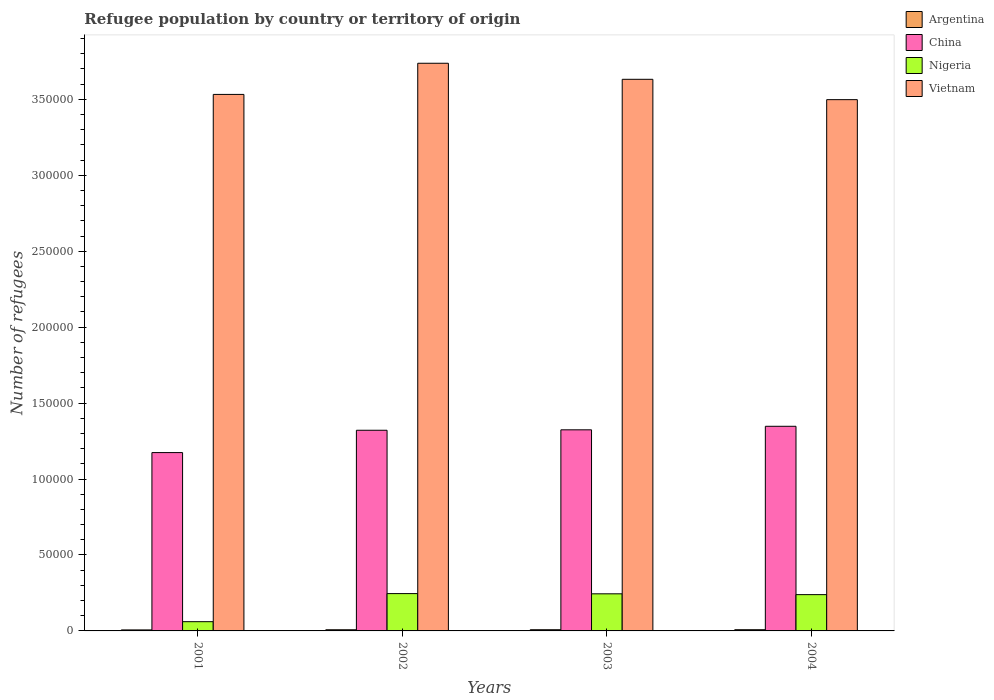How many different coloured bars are there?
Make the answer very short. 4. How many groups of bars are there?
Ensure brevity in your answer.  4. Are the number of bars per tick equal to the number of legend labels?
Your response must be concise. Yes. Are the number of bars on each tick of the X-axis equal?
Make the answer very short. Yes. How many bars are there on the 3rd tick from the right?
Provide a succinct answer. 4. In how many cases, is the number of bars for a given year not equal to the number of legend labels?
Your response must be concise. 0. What is the number of refugees in Argentina in 2001?
Ensure brevity in your answer.  659. Across all years, what is the maximum number of refugees in Argentina?
Provide a succinct answer. 796. Across all years, what is the minimum number of refugees in Argentina?
Your response must be concise. 659. What is the total number of refugees in China in the graph?
Your answer should be very brief. 5.17e+05. What is the difference between the number of refugees in Argentina in 2001 and that in 2002?
Provide a succinct answer. -112. What is the difference between the number of refugees in China in 2001 and the number of refugees in Nigeria in 2002?
Keep it short and to the point. 9.28e+04. What is the average number of refugees in Vietnam per year?
Ensure brevity in your answer.  3.60e+05. In the year 2001, what is the difference between the number of refugees in Argentina and number of refugees in China?
Give a very brief answer. -1.17e+05. What is the ratio of the number of refugees in China in 2001 to that in 2003?
Provide a succinct answer. 0.89. Is the difference between the number of refugees in Argentina in 2001 and 2003 greater than the difference between the number of refugees in China in 2001 and 2003?
Your answer should be compact. Yes. What is the difference between the highest and the second highest number of refugees in Vietnam?
Give a very brief answer. 1.06e+04. What is the difference between the highest and the lowest number of refugees in Nigeria?
Make the answer very short. 1.85e+04. Is the sum of the number of refugees in China in 2003 and 2004 greater than the maximum number of refugees in Argentina across all years?
Make the answer very short. Yes. What does the 3rd bar from the left in 2002 represents?
Give a very brief answer. Nigeria. What does the 3rd bar from the right in 2002 represents?
Provide a succinct answer. China. Is it the case that in every year, the sum of the number of refugees in Argentina and number of refugees in Nigeria is greater than the number of refugees in Vietnam?
Offer a very short reply. No. Are all the bars in the graph horizontal?
Offer a very short reply. No. How many years are there in the graph?
Make the answer very short. 4. What is the difference between two consecutive major ticks on the Y-axis?
Offer a terse response. 5.00e+04. Where does the legend appear in the graph?
Ensure brevity in your answer.  Top right. How many legend labels are there?
Offer a terse response. 4. How are the legend labels stacked?
Make the answer very short. Vertical. What is the title of the graph?
Offer a very short reply. Refugee population by country or territory of origin. What is the label or title of the Y-axis?
Provide a succinct answer. Number of refugees. What is the Number of refugees of Argentina in 2001?
Provide a succinct answer. 659. What is the Number of refugees in China in 2001?
Give a very brief answer. 1.17e+05. What is the Number of refugees in Nigeria in 2001?
Provide a succinct answer. 6084. What is the Number of refugees in Vietnam in 2001?
Keep it short and to the point. 3.53e+05. What is the Number of refugees in Argentina in 2002?
Provide a short and direct response. 771. What is the Number of refugees in China in 2002?
Your response must be concise. 1.32e+05. What is the Number of refugees in Nigeria in 2002?
Give a very brief answer. 2.46e+04. What is the Number of refugees of Vietnam in 2002?
Keep it short and to the point. 3.74e+05. What is the Number of refugees of Argentina in 2003?
Make the answer very short. 784. What is the Number of refugees of China in 2003?
Give a very brief answer. 1.32e+05. What is the Number of refugees in Nigeria in 2003?
Your response must be concise. 2.44e+04. What is the Number of refugees of Vietnam in 2003?
Your answer should be very brief. 3.63e+05. What is the Number of refugees in Argentina in 2004?
Give a very brief answer. 796. What is the Number of refugees in China in 2004?
Offer a very short reply. 1.35e+05. What is the Number of refugees in Nigeria in 2004?
Make the answer very short. 2.39e+04. What is the Number of refugees of Vietnam in 2004?
Ensure brevity in your answer.  3.50e+05. Across all years, what is the maximum Number of refugees of Argentina?
Your answer should be very brief. 796. Across all years, what is the maximum Number of refugees of China?
Your answer should be compact. 1.35e+05. Across all years, what is the maximum Number of refugees of Nigeria?
Your answer should be very brief. 2.46e+04. Across all years, what is the maximum Number of refugees in Vietnam?
Your answer should be compact. 3.74e+05. Across all years, what is the minimum Number of refugees of Argentina?
Ensure brevity in your answer.  659. Across all years, what is the minimum Number of refugees in China?
Offer a terse response. 1.17e+05. Across all years, what is the minimum Number of refugees of Nigeria?
Ensure brevity in your answer.  6084. Across all years, what is the minimum Number of refugees of Vietnam?
Keep it short and to the point. 3.50e+05. What is the total Number of refugees in Argentina in the graph?
Provide a succinct answer. 3010. What is the total Number of refugees of China in the graph?
Keep it short and to the point. 5.17e+05. What is the total Number of refugees in Nigeria in the graph?
Your response must be concise. 7.90e+04. What is the total Number of refugees of Vietnam in the graph?
Provide a short and direct response. 1.44e+06. What is the difference between the Number of refugees in Argentina in 2001 and that in 2002?
Make the answer very short. -112. What is the difference between the Number of refugees of China in 2001 and that in 2002?
Provide a succinct answer. -1.47e+04. What is the difference between the Number of refugees of Nigeria in 2001 and that in 2002?
Give a very brief answer. -1.85e+04. What is the difference between the Number of refugees in Vietnam in 2001 and that in 2002?
Your answer should be very brief. -2.05e+04. What is the difference between the Number of refugees in Argentina in 2001 and that in 2003?
Provide a succinct answer. -125. What is the difference between the Number of refugees of China in 2001 and that in 2003?
Your answer should be very brief. -1.50e+04. What is the difference between the Number of refugees in Nigeria in 2001 and that in 2003?
Give a very brief answer. -1.83e+04. What is the difference between the Number of refugees in Vietnam in 2001 and that in 2003?
Make the answer very short. -9955. What is the difference between the Number of refugees in Argentina in 2001 and that in 2004?
Give a very brief answer. -137. What is the difference between the Number of refugees of China in 2001 and that in 2004?
Ensure brevity in your answer.  -1.73e+04. What is the difference between the Number of refugees in Nigeria in 2001 and that in 2004?
Provide a short and direct response. -1.78e+04. What is the difference between the Number of refugees of Vietnam in 2001 and that in 2004?
Offer a very short reply. 3444. What is the difference between the Number of refugees of China in 2002 and that in 2003?
Your answer should be compact. -291. What is the difference between the Number of refugees in Nigeria in 2002 and that in 2003?
Your answer should be compact. 144. What is the difference between the Number of refugees in Vietnam in 2002 and that in 2003?
Ensure brevity in your answer.  1.06e+04. What is the difference between the Number of refugees of China in 2002 and that in 2004?
Give a very brief answer. -2609. What is the difference between the Number of refugees of Nigeria in 2002 and that in 2004?
Give a very brief answer. 680. What is the difference between the Number of refugees in Vietnam in 2002 and that in 2004?
Offer a very short reply. 2.40e+04. What is the difference between the Number of refugees of Argentina in 2003 and that in 2004?
Your response must be concise. -12. What is the difference between the Number of refugees in China in 2003 and that in 2004?
Give a very brief answer. -2318. What is the difference between the Number of refugees in Nigeria in 2003 and that in 2004?
Keep it short and to the point. 536. What is the difference between the Number of refugees in Vietnam in 2003 and that in 2004?
Provide a short and direct response. 1.34e+04. What is the difference between the Number of refugees in Argentina in 2001 and the Number of refugees in China in 2002?
Your answer should be very brief. -1.31e+05. What is the difference between the Number of refugees of Argentina in 2001 and the Number of refugees of Nigeria in 2002?
Provide a short and direct response. -2.39e+04. What is the difference between the Number of refugees in Argentina in 2001 and the Number of refugees in Vietnam in 2002?
Your response must be concise. -3.73e+05. What is the difference between the Number of refugees of China in 2001 and the Number of refugees of Nigeria in 2002?
Ensure brevity in your answer.  9.28e+04. What is the difference between the Number of refugees in China in 2001 and the Number of refugees in Vietnam in 2002?
Give a very brief answer. -2.56e+05. What is the difference between the Number of refugees of Nigeria in 2001 and the Number of refugees of Vietnam in 2002?
Your response must be concise. -3.68e+05. What is the difference between the Number of refugees in Argentina in 2001 and the Number of refugees in China in 2003?
Provide a short and direct response. -1.32e+05. What is the difference between the Number of refugees of Argentina in 2001 and the Number of refugees of Nigeria in 2003?
Provide a short and direct response. -2.38e+04. What is the difference between the Number of refugees of Argentina in 2001 and the Number of refugees of Vietnam in 2003?
Your answer should be compact. -3.63e+05. What is the difference between the Number of refugees in China in 2001 and the Number of refugees in Nigeria in 2003?
Your answer should be very brief. 9.30e+04. What is the difference between the Number of refugees in China in 2001 and the Number of refugees in Vietnam in 2003?
Keep it short and to the point. -2.46e+05. What is the difference between the Number of refugees in Nigeria in 2001 and the Number of refugees in Vietnam in 2003?
Provide a short and direct response. -3.57e+05. What is the difference between the Number of refugees in Argentina in 2001 and the Number of refugees in China in 2004?
Your response must be concise. -1.34e+05. What is the difference between the Number of refugees in Argentina in 2001 and the Number of refugees in Nigeria in 2004?
Provide a short and direct response. -2.32e+04. What is the difference between the Number of refugees in Argentina in 2001 and the Number of refugees in Vietnam in 2004?
Ensure brevity in your answer.  -3.49e+05. What is the difference between the Number of refugees in China in 2001 and the Number of refugees in Nigeria in 2004?
Keep it short and to the point. 9.35e+04. What is the difference between the Number of refugees of China in 2001 and the Number of refugees of Vietnam in 2004?
Your answer should be compact. -2.32e+05. What is the difference between the Number of refugees in Nigeria in 2001 and the Number of refugees in Vietnam in 2004?
Offer a very short reply. -3.44e+05. What is the difference between the Number of refugees of Argentina in 2002 and the Number of refugees of China in 2003?
Make the answer very short. -1.32e+05. What is the difference between the Number of refugees in Argentina in 2002 and the Number of refugees in Nigeria in 2003?
Offer a terse response. -2.37e+04. What is the difference between the Number of refugees in Argentina in 2002 and the Number of refugees in Vietnam in 2003?
Provide a short and direct response. -3.62e+05. What is the difference between the Number of refugees of China in 2002 and the Number of refugees of Nigeria in 2003?
Offer a terse response. 1.08e+05. What is the difference between the Number of refugees in China in 2002 and the Number of refugees in Vietnam in 2003?
Your answer should be compact. -2.31e+05. What is the difference between the Number of refugees of Nigeria in 2002 and the Number of refugees of Vietnam in 2003?
Your response must be concise. -3.39e+05. What is the difference between the Number of refugees in Argentina in 2002 and the Number of refugees in China in 2004?
Keep it short and to the point. -1.34e+05. What is the difference between the Number of refugees of Argentina in 2002 and the Number of refugees of Nigeria in 2004?
Offer a very short reply. -2.31e+04. What is the difference between the Number of refugees in Argentina in 2002 and the Number of refugees in Vietnam in 2004?
Ensure brevity in your answer.  -3.49e+05. What is the difference between the Number of refugees of China in 2002 and the Number of refugees of Nigeria in 2004?
Provide a short and direct response. 1.08e+05. What is the difference between the Number of refugees of China in 2002 and the Number of refugees of Vietnam in 2004?
Offer a very short reply. -2.18e+05. What is the difference between the Number of refugees in Nigeria in 2002 and the Number of refugees in Vietnam in 2004?
Offer a very short reply. -3.25e+05. What is the difference between the Number of refugees in Argentina in 2003 and the Number of refugees in China in 2004?
Offer a terse response. -1.34e+05. What is the difference between the Number of refugees in Argentina in 2003 and the Number of refugees in Nigeria in 2004?
Provide a short and direct response. -2.31e+04. What is the difference between the Number of refugees in Argentina in 2003 and the Number of refugees in Vietnam in 2004?
Provide a succinct answer. -3.49e+05. What is the difference between the Number of refugees in China in 2003 and the Number of refugees in Nigeria in 2004?
Provide a short and direct response. 1.09e+05. What is the difference between the Number of refugees in China in 2003 and the Number of refugees in Vietnam in 2004?
Give a very brief answer. -2.17e+05. What is the difference between the Number of refugees in Nigeria in 2003 and the Number of refugees in Vietnam in 2004?
Your response must be concise. -3.25e+05. What is the average Number of refugees in Argentina per year?
Give a very brief answer. 752.5. What is the average Number of refugees of China per year?
Offer a terse response. 1.29e+05. What is the average Number of refugees of Nigeria per year?
Keep it short and to the point. 1.97e+04. What is the average Number of refugees in Vietnam per year?
Make the answer very short. 3.60e+05. In the year 2001, what is the difference between the Number of refugees of Argentina and Number of refugees of China?
Ensure brevity in your answer.  -1.17e+05. In the year 2001, what is the difference between the Number of refugees of Argentina and Number of refugees of Nigeria?
Ensure brevity in your answer.  -5425. In the year 2001, what is the difference between the Number of refugees of Argentina and Number of refugees of Vietnam?
Provide a short and direct response. -3.53e+05. In the year 2001, what is the difference between the Number of refugees in China and Number of refugees in Nigeria?
Ensure brevity in your answer.  1.11e+05. In the year 2001, what is the difference between the Number of refugees of China and Number of refugees of Vietnam?
Make the answer very short. -2.36e+05. In the year 2001, what is the difference between the Number of refugees of Nigeria and Number of refugees of Vietnam?
Give a very brief answer. -3.47e+05. In the year 2002, what is the difference between the Number of refugees in Argentina and Number of refugees in China?
Ensure brevity in your answer.  -1.31e+05. In the year 2002, what is the difference between the Number of refugees of Argentina and Number of refugees of Nigeria?
Make the answer very short. -2.38e+04. In the year 2002, what is the difference between the Number of refugees of Argentina and Number of refugees of Vietnam?
Provide a short and direct response. -3.73e+05. In the year 2002, what is the difference between the Number of refugees of China and Number of refugees of Nigeria?
Your response must be concise. 1.08e+05. In the year 2002, what is the difference between the Number of refugees of China and Number of refugees of Vietnam?
Make the answer very short. -2.42e+05. In the year 2002, what is the difference between the Number of refugees of Nigeria and Number of refugees of Vietnam?
Your answer should be compact. -3.49e+05. In the year 2003, what is the difference between the Number of refugees of Argentina and Number of refugees of China?
Your answer should be very brief. -1.32e+05. In the year 2003, what is the difference between the Number of refugees of Argentina and Number of refugees of Nigeria?
Your response must be concise. -2.36e+04. In the year 2003, what is the difference between the Number of refugees in Argentina and Number of refugees in Vietnam?
Your answer should be very brief. -3.62e+05. In the year 2003, what is the difference between the Number of refugees in China and Number of refugees in Nigeria?
Make the answer very short. 1.08e+05. In the year 2003, what is the difference between the Number of refugees of China and Number of refugees of Vietnam?
Your answer should be compact. -2.31e+05. In the year 2003, what is the difference between the Number of refugees in Nigeria and Number of refugees in Vietnam?
Make the answer very short. -3.39e+05. In the year 2004, what is the difference between the Number of refugees of Argentina and Number of refugees of China?
Your answer should be very brief. -1.34e+05. In the year 2004, what is the difference between the Number of refugees of Argentina and Number of refugees of Nigeria?
Give a very brief answer. -2.31e+04. In the year 2004, what is the difference between the Number of refugees in Argentina and Number of refugees in Vietnam?
Keep it short and to the point. -3.49e+05. In the year 2004, what is the difference between the Number of refugees of China and Number of refugees of Nigeria?
Your answer should be compact. 1.11e+05. In the year 2004, what is the difference between the Number of refugees of China and Number of refugees of Vietnam?
Keep it short and to the point. -2.15e+05. In the year 2004, what is the difference between the Number of refugees in Nigeria and Number of refugees in Vietnam?
Your response must be concise. -3.26e+05. What is the ratio of the Number of refugees of Argentina in 2001 to that in 2002?
Offer a terse response. 0.85. What is the ratio of the Number of refugees of China in 2001 to that in 2002?
Make the answer very short. 0.89. What is the ratio of the Number of refugees of Nigeria in 2001 to that in 2002?
Your answer should be very brief. 0.25. What is the ratio of the Number of refugees in Vietnam in 2001 to that in 2002?
Offer a terse response. 0.95. What is the ratio of the Number of refugees in Argentina in 2001 to that in 2003?
Your response must be concise. 0.84. What is the ratio of the Number of refugees of China in 2001 to that in 2003?
Provide a short and direct response. 0.89. What is the ratio of the Number of refugees in Nigeria in 2001 to that in 2003?
Keep it short and to the point. 0.25. What is the ratio of the Number of refugees in Vietnam in 2001 to that in 2003?
Give a very brief answer. 0.97. What is the ratio of the Number of refugees of Argentina in 2001 to that in 2004?
Ensure brevity in your answer.  0.83. What is the ratio of the Number of refugees in China in 2001 to that in 2004?
Ensure brevity in your answer.  0.87. What is the ratio of the Number of refugees in Nigeria in 2001 to that in 2004?
Give a very brief answer. 0.25. What is the ratio of the Number of refugees of Vietnam in 2001 to that in 2004?
Ensure brevity in your answer.  1.01. What is the ratio of the Number of refugees in Argentina in 2002 to that in 2003?
Provide a succinct answer. 0.98. What is the ratio of the Number of refugees in Nigeria in 2002 to that in 2003?
Offer a terse response. 1.01. What is the ratio of the Number of refugees of Vietnam in 2002 to that in 2003?
Offer a terse response. 1.03. What is the ratio of the Number of refugees of Argentina in 2002 to that in 2004?
Offer a terse response. 0.97. What is the ratio of the Number of refugees in China in 2002 to that in 2004?
Provide a succinct answer. 0.98. What is the ratio of the Number of refugees in Nigeria in 2002 to that in 2004?
Give a very brief answer. 1.03. What is the ratio of the Number of refugees in Vietnam in 2002 to that in 2004?
Offer a terse response. 1.07. What is the ratio of the Number of refugees of Argentina in 2003 to that in 2004?
Your answer should be very brief. 0.98. What is the ratio of the Number of refugees of China in 2003 to that in 2004?
Your answer should be very brief. 0.98. What is the ratio of the Number of refugees in Nigeria in 2003 to that in 2004?
Give a very brief answer. 1.02. What is the ratio of the Number of refugees in Vietnam in 2003 to that in 2004?
Your answer should be very brief. 1.04. What is the difference between the highest and the second highest Number of refugees in Argentina?
Make the answer very short. 12. What is the difference between the highest and the second highest Number of refugees in China?
Keep it short and to the point. 2318. What is the difference between the highest and the second highest Number of refugees of Nigeria?
Keep it short and to the point. 144. What is the difference between the highest and the second highest Number of refugees of Vietnam?
Offer a very short reply. 1.06e+04. What is the difference between the highest and the lowest Number of refugees of Argentina?
Keep it short and to the point. 137. What is the difference between the highest and the lowest Number of refugees of China?
Give a very brief answer. 1.73e+04. What is the difference between the highest and the lowest Number of refugees in Nigeria?
Provide a short and direct response. 1.85e+04. What is the difference between the highest and the lowest Number of refugees in Vietnam?
Offer a very short reply. 2.40e+04. 